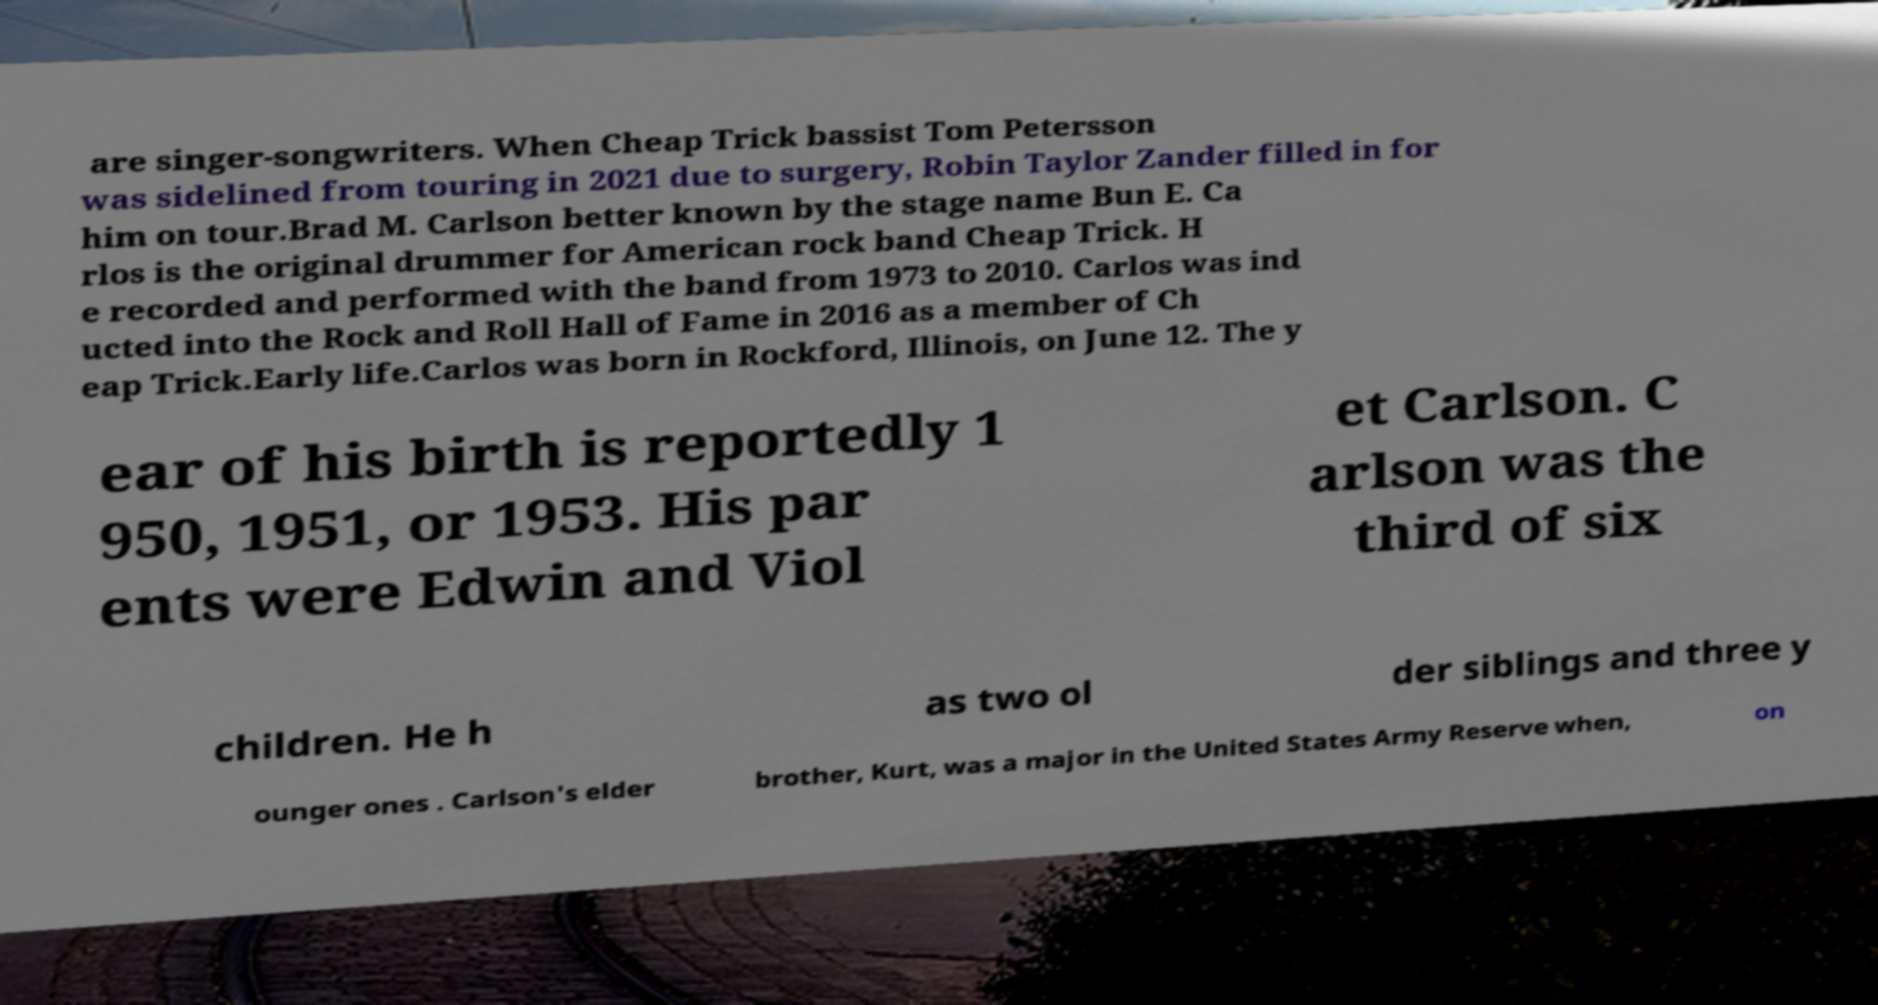Could you extract and type out the text from this image? are singer-songwriters. When Cheap Trick bassist Tom Petersson was sidelined from touring in 2021 due to surgery, Robin Taylor Zander filled in for him on tour.Brad M. Carlson better known by the stage name Bun E. Ca rlos is the original drummer for American rock band Cheap Trick. H e recorded and performed with the band from 1973 to 2010. Carlos was ind ucted into the Rock and Roll Hall of Fame in 2016 as a member of Ch eap Trick.Early life.Carlos was born in Rockford, Illinois, on June 12. The y ear of his birth is reportedly 1 950, 1951, or 1953. His par ents were Edwin and Viol et Carlson. C arlson was the third of six children. He h as two ol der siblings and three y ounger ones . Carlson's elder brother, Kurt, was a major in the United States Army Reserve when, on 